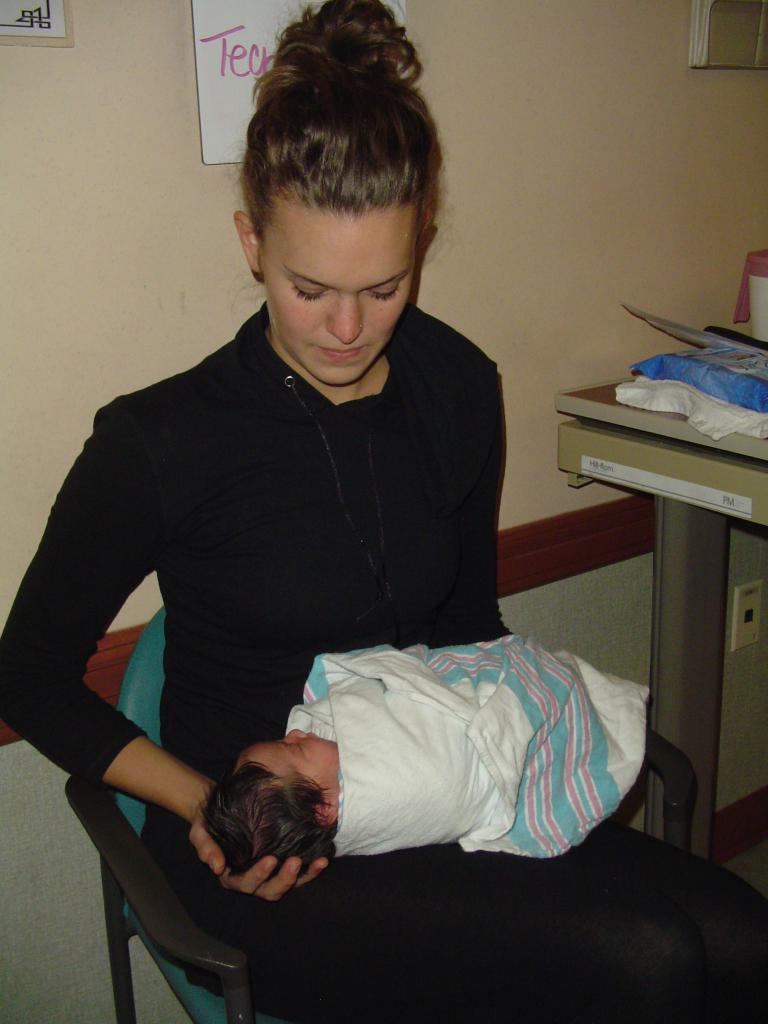How would you summarize this image in a sentence or two? In this image I can see a person sitting on the chair and holding a baby. The person is wearing black dress, background I can see white color board attached to the wall and the wall is in cream color. 